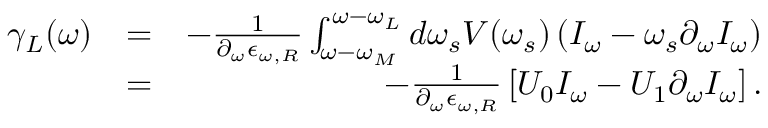Convert formula to latex. <formula><loc_0><loc_0><loc_500><loc_500>\begin{array} { r l r } { \gamma _ { L } ( \omega ) } & { = } & { - \frac { 1 } { \partial _ { \omega } \epsilon _ { \omega , R } } \int _ { \omega - \omega _ { M } } ^ { \omega - \omega _ { L } } d \omega _ { s } V ( \omega _ { s } ) \left ( I _ { \omega } - \omega _ { s } \partial _ { \omega } I _ { \omega } \right ) } \\ & { = } & { - \frac { 1 } { \partial _ { \omega } \epsilon _ { \omega , R } } \left [ U _ { 0 } I _ { \omega } - U _ { 1 } \partial _ { \omega } I _ { \omega } \right ] . } \end{array}</formula> 